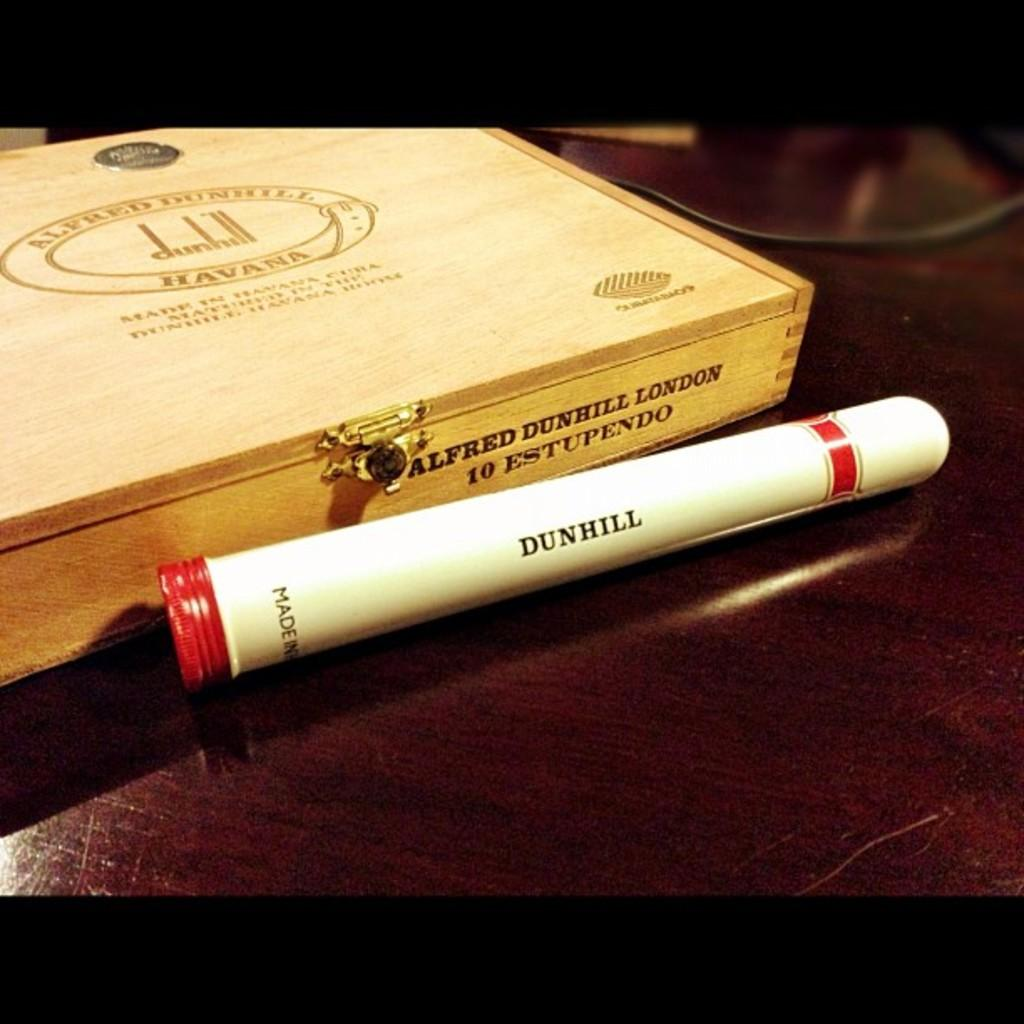Provide a one-sentence caption for the provided image. a cigar and cigar box placed on the table. 